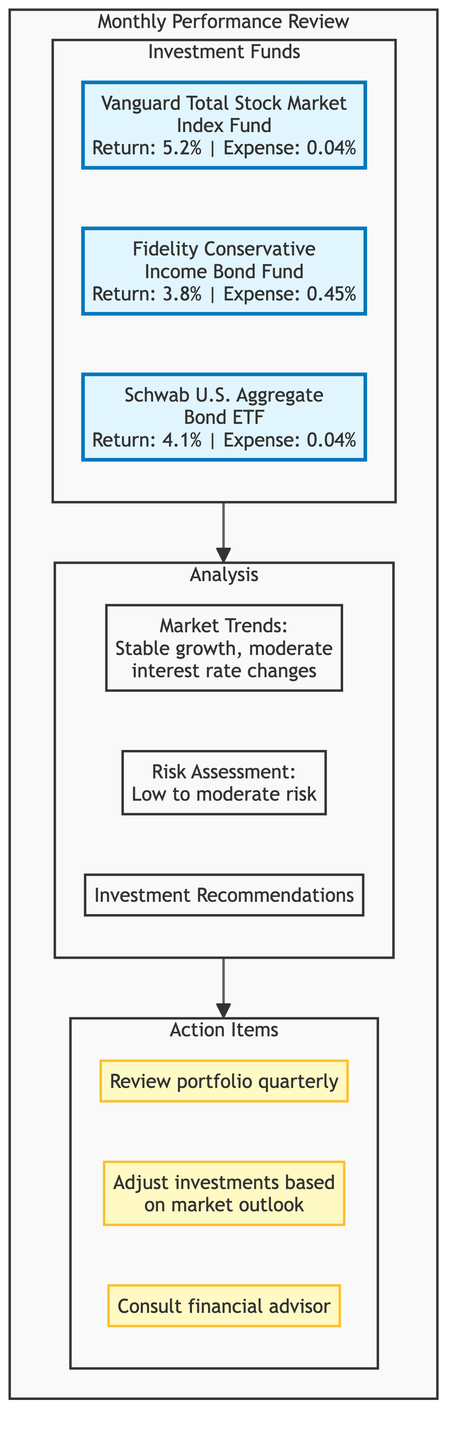What is the performance return of the Vanguard Total Stock Market Index Fund? The diagram shows that the Vanguard Total Stock Market Index Fund has a performance return of 5.2%.
Answer: 5.2% What is the expense ratio of the Fidelity Conservative Income Bond Fund? The diagram indicates that the expense ratio of the Fidelity Conservative Income Bond Fund is 0.45%.
Answer: 0.45% How many investment funds are listed in the diagram? The diagram presents a total of three investment funds: Vanguard Total Stock Market Index Fund, Fidelity Conservative Income Bond Fund, and Schwab U.S. Aggregate Bond ETF.
Answer: 3 What is the main market trend identified in the analysis section? The analysis section of the diagram indicates the market trend as stable economic growth with moderate interest rate changes.
Answer: Stable economic growth What investment recommendation suggests an allocation increase? The diagram includes the recommendation to increase allocation to municipal bonds, indicating a strategic move towards stability and safety.
Answer: Increase allocation to municipal bonds What is the risk assessment mentioned in the analysis? The risk assessment stated in the analysis section is low to moderate risk associated with government and corporate bonds.
Answer: Low to moderate risk Which action item suggests a periodic review? Among the action items listed, the entry for reviewing the portfolio quarterly suggests a systematic approach to investment management.
Answer: Review portfolio quarterly What type of fund is the Schwab U.S. Aggregate Bond ETF? In the diagram, the Schwab U.S. Aggregate Bond ETF is classified as an Exchange-Traded Fund.
Answer: Exchange-Traded Fund What are the two areas included in the analysis section? The analysis section contains two distinct areas: Market Trends and Risk Assessment. The third area is Investment Recommendations.
Answer: Market Trends, Risk Assessment What is the duration of the Fidelity Conservative Income Bond Fund? The duration listed for the Fidelity Conservative Income Bond Fund according to the diagram is 4.5 years.
Answer: 4.5 years 